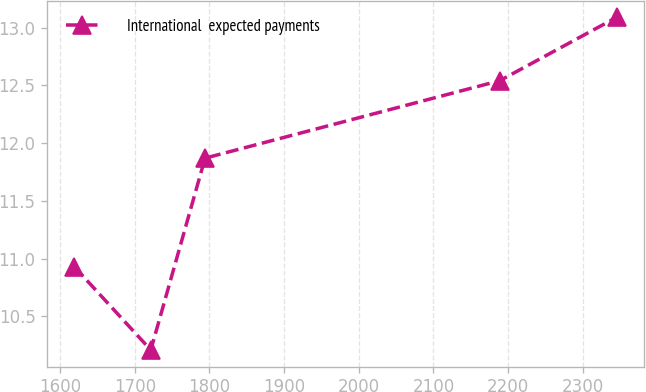Convert chart to OTSL. <chart><loc_0><loc_0><loc_500><loc_500><line_chart><ecel><fcel>International  expected payments<nl><fcel>1619.16<fcel>10.93<nl><fcel>1721.49<fcel>10.21<nl><fcel>1794.16<fcel>11.87<nl><fcel>2188.72<fcel>12.54<nl><fcel>2345.86<fcel>13.09<nl></chart> 